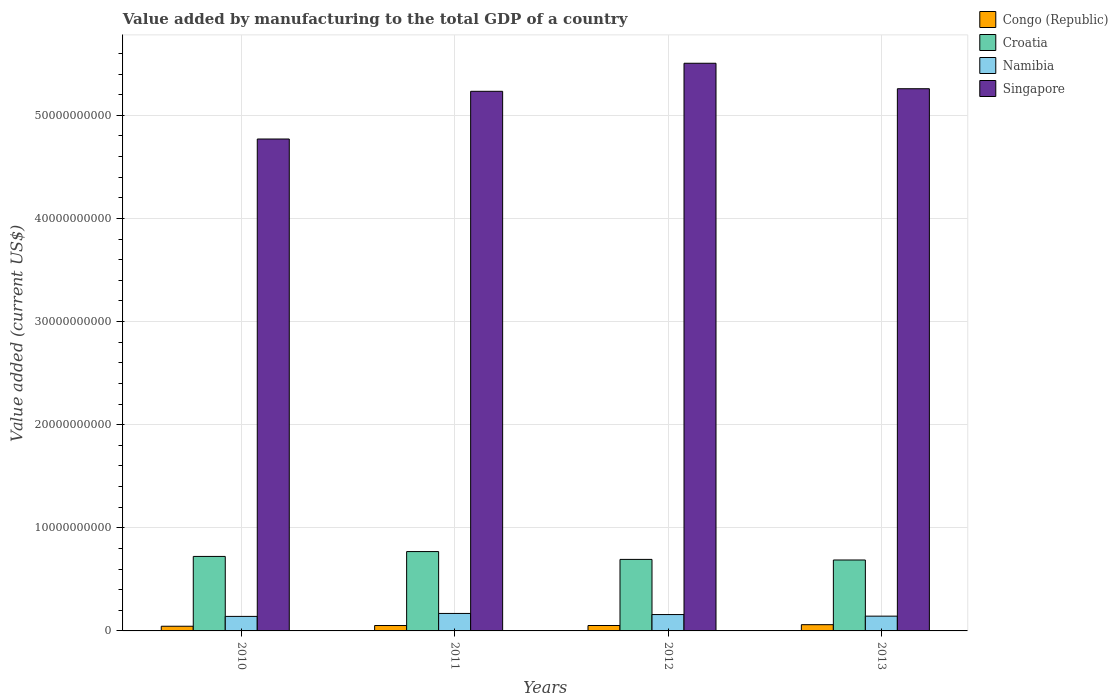How many different coloured bars are there?
Give a very brief answer. 4. How many bars are there on the 1st tick from the left?
Make the answer very short. 4. How many bars are there on the 1st tick from the right?
Provide a short and direct response. 4. What is the label of the 4th group of bars from the left?
Your response must be concise. 2013. In how many cases, is the number of bars for a given year not equal to the number of legend labels?
Provide a succinct answer. 0. What is the value added by manufacturing to the total GDP in Singapore in 2013?
Ensure brevity in your answer.  5.26e+1. Across all years, what is the maximum value added by manufacturing to the total GDP in Namibia?
Offer a very short reply. 1.69e+09. Across all years, what is the minimum value added by manufacturing to the total GDP in Congo (Republic)?
Provide a succinct answer. 4.54e+08. In which year was the value added by manufacturing to the total GDP in Singapore maximum?
Your response must be concise. 2012. What is the total value added by manufacturing to the total GDP in Croatia in the graph?
Give a very brief answer. 2.87e+1. What is the difference between the value added by manufacturing to the total GDP in Singapore in 2011 and that in 2012?
Keep it short and to the point. -2.72e+09. What is the difference between the value added by manufacturing to the total GDP in Congo (Republic) in 2010 and the value added by manufacturing to the total GDP in Croatia in 2012?
Offer a terse response. -6.48e+09. What is the average value added by manufacturing to the total GDP in Croatia per year?
Ensure brevity in your answer.  7.18e+09. In the year 2010, what is the difference between the value added by manufacturing to the total GDP in Singapore and value added by manufacturing to the total GDP in Croatia?
Ensure brevity in your answer.  4.05e+1. What is the ratio of the value added by manufacturing to the total GDP in Croatia in 2010 to that in 2012?
Provide a succinct answer. 1.04. Is the difference between the value added by manufacturing to the total GDP in Singapore in 2010 and 2011 greater than the difference between the value added by manufacturing to the total GDP in Croatia in 2010 and 2011?
Give a very brief answer. No. What is the difference between the highest and the second highest value added by manufacturing to the total GDP in Congo (Republic)?
Keep it short and to the point. 8.02e+07. What is the difference between the highest and the lowest value added by manufacturing to the total GDP in Congo (Republic)?
Your answer should be very brief. 1.51e+08. What does the 2nd bar from the left in 2010 represents?
Offer a terse response. Croatia. What does the 2nd bar from the right in 2013 represents?
Offer a very short reply. Namibia. Is it the case that in every year, the sum of the value added by manufacturing to the total GDP in Congo (Republic) and value added by manufacturing to the total GDP in Namibia is greater than the value added by manufacturing to the total GDP in Singapore?
Offer a very short reply. No. How many bars are there?
Provide a succinct answer. 16. Are all the bars in the graph horizontal?
Your answer should be compact. No. How many years are there in the graph?
Make the answer very short. 4. Does the graph contain any zero values?
Give a very brief answer. No. Does the graph contain grids?
Your answer should be compact. Yes. How many legend labels are there?
Your answer should be very brief. 4. How are the legend labels stacked?
Ensure brevity in your answer.  Vertical. What is the title of the graph?
Offer a very short reply. Value added by manufacturing to the total GDP of a country. What is the label or title of the Y-axis?
Your answer should be very brief. Value added (current US$). What is the Value added (current US$) of Congo (Republic) in 2010?
Your answer should be compact. 4.54e+08. What is the Value added (current US$) of Croatia in 2010?
Offer a terse response. 7.22e+09. What is the Value added (current US$) of Namibia in 2010?
Your answer should be compact. 1.41e+09. What is the Value added (current US$) of Singapore in 2010?
Your response must be concise. 4.77e+1. What is the Value added (current US$) in Congo (Republic) in 2011?
Offer a terse response. 5.24e+08. What is the Value added (current US$) of Croatia in 2011?
Keep it short and to the point. 7.69e+09. What is the Value added (current US$) of Namibia in 2011?
Give a very brief answer. 1.69e+09. What is the Value added (current US$) of Singapore in 2011?
Your answer should be very brief. 5.23e+1. What is the Value added (current US$) of Congo (Republic) in 2012?
Your answer should be very brief. 5.25e+08. What is the Value added (current US$) of Croatia in 2012?
Your answer should be very brief. 6.94e+09. What is the Value added (current US$) of Namibia in 2012?
Make the answer very short. 1.59e+09. What is the Value added (current US$) of Singapore in 2012?
Give a very brief answer. 5.50e+1. What is the Value added (current US$) in Congo (Republic) in 2013?
Offer a terse response. 6.05e+08. What is the Value added (current US$) of Croatia in 2013?
Provide a short and direct response. 6.88e+09. What is the Value added (current US$) of Namibia in 2013?
Provide a short and direct response. 1.43e+09. What is the Value added (current US$) in Singapore in 2013?
Your answer should be very brief. 5.26e+1. Across all years, what is the maximum Value added (current US$) in Congo (Republic)?
Make the answer very short. 6.05e+08. Across all years, what is the maximum Value added (current US$) in Croatia?
Your answer should be very brief. 7.69e+09. Across all years, what is the maximum Value added (current US$) in Namibia?
Make the answer very short. 1.69e+09. Across all years, what is the maximum Value added (current US$) in Singapore?
Keep it short and to the point. 5.50e+1. Across all years, what is the minimum Value added (current US$) in Congo (Republic)?
Ensure brevity in your answer.  4.54e+08. Across all years, what is the minimum Value added (current US$) in Croatia?
Provide a short and direct response. 6.88e+09. Across all years, what is the minimum Value added (current US$) in Namibia?
Provide a succinct answer. 1.41e+09. Across all years, what is the minimum Value added (current US$) in Singapore?
Offer a very short reply. 4.77e+1. What is the total Value added (current US$) of Congo (Republic) in the graph?
Your answer should be very brief. 2.11e+09. What is the total Value added (current US$) in Croatia in the graph?
Ensure brevity in your answer.  2.87e+1. What is the total Value added (current US$) in Namibia in the graph?
Give a very brief answer. 6.12e+09. What is the total Value added (current US$) of Singapore in the graph?
Offer a very short reply. 2.08e+11. What is the difference between the Value added (current US$) in Congo (Republic) in 2010 and that in 2011?
Offer a very short reply. -6.98e+07. What is the difference between the Value added (current US$) in Croatia in 2010 and that in 2011?
Give a very brief answer. -4.71e+08. What is the difference between the Value added (current US$) in Namibia in 2010 and that in 2011?
Give a very brief answer. -2.87e+08. What is the difference between the Value added (current US$) in Singapore in 2010 and that in 2011?
Offer a very short reply. -4.63e+09. What is the difference between the Value added (current US$) of Congo (Republic) in 2010 and that in 2012?
Your answer should be very brief. -7.08e+07. What is the difference between the Value added (current US$) in Croatia in 2010 and that in 2012?
Provide a short and direct response. 2.88e+08. What is the difference between the Value added (current US$) of Namibia in 2010 and that in 2012?
Keep it short and to the point. -1.79e+08. What is the difference between the Value added (current US$) in Singapore in 2010 and that in 2012?
Make the answer very short. -7.35e+09. What is the difference between the Value added (current US$) of Congo (Republic) in 2010 and that in 2013?
Your answer should be very brief. -1.51e+08. What is the difference between the Value added (current US$) of Croatia in 2010 and that in 2013?
Offer a very short reply. 3.45e+08. What is the difference between the Value added (current US$) in Namibia in 2010 and that in 2013?
Your answer should be very brief. -2.44e+07. What is the difference between the Value added (current US$) of Singapore in 2010 and that in 2013?
Give a very brief answer. -4.88e+09. What is the difference between the Value added (current US$) in Congo (Republic) in 2011 and that in 2012?
Your answer should be compact. -9.99e+05. What is the difference between the Value added (current US$) of Croatia in 2011 and that in 2012?
Your response must be concise. 7.59e+08. What is the difference between the Value added (current US$) in Namibia in 2011 and that in 2012?
Offer a terse response. 1.08e+08. What is the difference between the Value added (current US$) in Singapore in 2011 and that in 2012?
Your response must be concise. -2.72e+09. What is the difference between the Value added (current US$) in Congo (Republic) in 2011 and that in 2013?
Provide a succinct answer. -8.12e+07. What is the difference between the Value added (current US$) in Croatia in 2011 and that in 2013?
Make the answer very short. 8.16e+08. What is the difference between the Value added (current US$) in Namibia in 2011 and that in 2013?
Offer a terse response. 2.62e+08. What is the difference between the Value added (current US$) in Singapore in 2011 and that in 2013?
Make the answer very short. -2.50e+08. What is the difference between the Value added (current US$) in Congo (Republic) in 2012 and that in 2013?
Your answer should be very brief. -8.02e+07. What is the difference between the Value added (current US$) of Croatia in 2012 and that in 2013?
Give a very brief answer. 5.71e+07. What is the difference between the Value added (current US$) of Namibia in 2012 and that in 2013?
Your answer should be compact. 1.55e+08. What is the difference between the Value added (current US$) in Singapore in 2012 and that in 2013?
Offer a terse response. 2.47e+09. What is the difference between the Value added (current US$) of Congo (Republic) in 2010 and the Value added (current US$) of Croatia in 2011?
Offer a very short reply. -7.24e+09. What is the difference between the Value added (current US$) in Congo (Republic) in 2010 and the Value added (current US$) in Namibia in 2011?
Provide a succinct answer. -1.24e+09. What is the difference between the Value added (current US$) of Congo (Republic) in 2010 and the Value added (current US$) of Singapore in 2011?
Your answer should be compact. -5.19e+1. What is the difference between the Value added (current US$) of Croatia in 2010 and the Value added (current US$) of Namibia in 2011?
Offer a very short reply. 5.53e+09. What is the difference between the Value added (current US$) of Croatia in 2010 and the Value added (current US$) of Singapore in 2011?
Your answer should be very brief. -4.51e+1. What is the difference between the Value added (current US$) in Namibia in 2010 and the Value added (current US$) in Singapore in 2011?
Provide a succinct answer. -5.09e+1. What is the difference between the Value added (current US$) in Congo (Republic) in 2010 and the Value added (current US$) in Croatia in 2012?
Your answer should be very brief. -6.48e+09. What is the difference between the Value added (current US$) in Congo (Republic) in 2010 and the Value added (current US$) in Namibia in 2012?
Keep it short and to the point. -1.13e+09. What is the difference between the Value added (current US$) of Congo (Republic) in 2010 and the Value added (current US$) of Singapore in 2012?
Your answer should be very brief. -5.46e+1. What is the difference between the Value added (current US$) in Croatia in 2010 and the Value added (current US$) in Namibia in 2012?
Your answer should be very brief. 5.64e+09. What is the difference between the Value added (current US$) in Croatia in 2010 and the Value added (current US$) in Singapore in 2012?
Offer a terse response. -4.78e+1. What is the difference between the Value added (current US$) of Namibia in 2010 and the Value added (current US$) of Singapore in 2012?
Your answer should be very brief. -5.36e+1. What is the difference between the Value added (current US$) in Congo (Republic) in 2010 and the Value added (current US$) in Croatia in 2013?
Your response must be concise. -6.42e+09. What is the difference between the Value added (current US$) in Congo (Republic) in 2010 and the Value added (current US$) in Namibia in 2013?
Give a very brief answer. -9.78e+08. What is the difference between the Value added (current US$) of Congo (Republic) in 2010 and the Value added (current US$) of Singapore in 2013?
Ensure brevity in your answer.  -5.21e+1. What is the difference between the Value added (current US$) in Croatia in 2010 and the Value added (current US$) in Namibia in 2013?
Make the answer very short. 5.79e+09. What is the difference between the Value added (current US$) in Croatia in 2010 and the Value added (current US$) in Singapore in 2013?
Make the answer very short. -4.54e+1. What is the difference between the Value added (current US$) of Namibia in 2010 and the Value added (current US$) of Singapore in 2013?
Make the answer very short. -5.12e+1. What is the difference between the Value added (current US$) in Congo (Republic) in 2011 and the Value added (current US$) in Croatia in 2012?
Make the answer very short. -6.41e+09. What is the difference between the Value added (current US$) in Congo (Republic) in 2011 and the Value added (current US$) in Namibia in 2012?
Your answer should be very brief. -1.06e+09. What is the difference between the Value added (current US$) of Congo (Republic) in 2011 and the Value added (current US$) of Singapore in 2012?
Your response must be concise. -5.45e+1. What is the difference between the Value added (current US$) of Croatia in 2011 and the Value added (current US$) of Namibia in 2012?
Offer a terse response. 6.11e+09. What is the difference between the Value added (current US$) of Croatia in 2011 and the Value added (current US$) of Singapore in 2012?
Offer a terse response. -4.74e+1. What is the difference between the Value added (current US$) of Namibia in 2011 and the Value added (current US$) of Singapore in 2012?
Keep it short and to the point. -5.34e+1. What is the difference between the Value added (current US$) in Congo (Republic) in 2011 and the Value added (current US$) in Croatia in 2013?
Your response must be concise. -6.35e+09. What is the difference between the Value added (current US$) of Congo (Republic) in 2011 and the Value added (current US$) of Namibia in 2013?
Keep it short and to the point. -9.08e+08. What is the difference between the Value added (current US$) in Congo (Republic) in 2011 and the Value added (current US$) in Singapore in 2013?
Keep it short and to the point. -5.21e+1. What is the difference between the Value added (current US$) of Croatia in 2011 and the Value added (current US$) of Namibia in 2013?
Ensure brevity in your answer.  6.26e+09. What is the difference between the Value added (current US$) of Croatia in 2011 and the Value added (current US$) of Singapore in 2013?
Ensure brevity in your answer.  -4.49e+1. What is the difference between the Value added (current US$) of Namibia in 2011 and the Value added (current US$) of Singapore in 2013?
Your answer should be compact. -5.09e+1. What is the difference between the Value added (current US$) in Congo (Republic) in 2012 and the Value added (current US$) in Croatia in 2013?
Keep it short and to the point. -6.35e+09. What is the difference between the Value added (current US$) in Congo (Republic) in 2012 and the Value added (current US$) in Namibia in 2013?
Your answer should be very brief. -9.07e+08. What is the difference between the Value added (current US$) in Congo (Republic) in 2012 and the Value added (current US$) in Singapore in 2013?
Provide a short and direct response. -5.21e+1. What is the difference between the Value added (current US$) in Croatia in 2012 and the Value added (current US$) in Namibia in 2013?
Your answer should be compact. 5.50e+09. What is the difference between the Value added (current US$) in Croatia in 2012 and the Value added (current US$) in Singapore in 2013?
Ensure brevity in your answer.  -4.56e+1. What is the difference between the Value added (current US$) in Namibia in 2012 and the Value added (current US$) in Singapore in 2013?
Provide a succinct answer. -5.10e+1. What is the average Value added (current US$) in Congo (Republic) per year?
Your answer should be very brief. 5.27e+08. What is the average Value added (current US$) of Croatia per year?
Your answer should be compact. 7.18e+09. What is the average Value added (current US$) in Namibia per year?
Offer a very short reply. 1.53e+09. What is the average Value added (current US$) of Singapore per year?
Offer a terse response. 5.19e+1. In the year 2010, what is the difference between the Value added (current US$) of Congo (Republic) and Value added (current US$) of Croatia?
Give a very brief answer. -6.77e+09. In the year 2010, what is the difference between the Value added (current US$) in Congo (Republic) and Value added (current US$) in Namibia?
Offer a very short reply. -9.53e+08. In the year 2010, what is the difference between the Value added (current US$) of Congo (Republic) and Value added (current US$) of Singapore?
Your answer should be very brief. -4.72e+1. In the year 2010, what is the difference between the Value added (current US$) in Croatia and Value added (current US$) in Namibia?
Provide a succinct answer. 5.82e+09. In the year 2010, what is the difference between the Value added (current US$) in Croatia and Value added (current US$) in Singapore?
Offer a very short reply. -4.05e+1. In the year 2010, what is the difference between the Value added (current US$) of Namibia and Value added (current US$) of Singapore?
Keep it short and to the point. -4.63e+1. In the year 2011, what is the difference between the Value added (current US$) of Congo (Republic) and Value added (current US$) of Croatia?
Keep it short and to the point. -7.17e+09. In the year 2011, what is the difference between the Value added (current US$) in Congo (Republic) and Value added (current US$) in Namibia?
Your answer should be very brief. -1.17e+09. In the year 2011, what is the difference between the Value added (current US$) of Congo (Republic) and Value added (current US$) of Singapore?
Your answer should be compact. -5.18e+1. In the year 2011, what is the difference between the Value added (current US$) of Croatia and Value added (current US$) of Namibia?
Provide a succinct answer. 6.00e+09. In the year 2011, what is the difference between the Value added (current US$) in Croatia and Value added (current US$) in Singapore?
Offer a very short reply. -4.46e+1. In the year 2011, what is the difference between the Value added (current US$) in Namibia and Value added (current US$) in Singapore?
Offer a terse response. -5.06e+1. In the year 2012, what is the difference between the Value added (current US$) in Congo (Republic) and Value added (current US$) in Croatia?
Ensure brevity in your answer.  -6.41e+09. In the year 2012, what is the difference between the Value added (current US$) in Congo (Republic) and Value added (current US$) in Namibia?
Offer a terse response. -1.06e+09. In the year 2012, what is the difference between the Value added (current US$) of Congo (Republic) and Value added (current US$) of Singapore?
Your answer should be compact. -5.45e+1. In the year 2012, what is the difference between the Value added (current US$) in Croatia and Value added (current US$) in Namibia?
Give a very brief answer. 5.35e+09. In the year 2012, what is the difference between the Value added (current US$) of Croatia and Value added (current US$) of Singapore?
Your answer should be compact. -4.81e+1. In the year 2012, what is the difference between the Value added (current US$) in Namibia and Value added (current US$) in Singapore?
Ensure brevity in your answer.  -5.35e+1. In the year 2013, what is the difference between the Value added (current US$) in Congo (Republic) and Value added (current US$) in Croatia?
Your response must be concise. -6.27e+09. In the year 2013, what is the difference between the Value added (current US$) of Congo (Republic) and Value added (current US$) of Namibia?
Keep it short and to the point. -8.27e+08. In the year 2013, what is the difference between the Value added (current US$) of Congo (Republic) and Value added (current US$) of Singapore?
Provide a succinct answer. -5.20e+1. In the year 2013, what is the difference between the Value added (current US$) in Croatia and Value added (current US$) in Namibia?
Your answer should be very brief. 5.45e+09. In the year 2013, what is the difference between the Value added (current US$) of Croatia and Value added (current US$) of Singapore?
Your answer should be compact. -4.57e+1. In the year 2013, what is the difference between the Value added (current US$) of Namibia and Value added (current US$) of Singapore?
Ensure brevity in your answer.  -5.11e+1. What is the ratio of the Value added (current US$) in Congo (Republic) in 2010 to that in 2011?
Provide a short and direct response. 0.87. What is the ratio of the Value added (current US$) in Croatia in 2010 to that in 2011?
Make the answer very short. 0.94. What is the ratio of the Value added (current US$) in Namibia in 2010 to that in 2011?
Offer a very short reply. 0.83. What is the ratio of the Value added (current US$) of Singapore in 2010 to that in 2011?
Offer a very short reply. 0.91. What is the ratio of the Value added (current US$) of Congo (Republic) in 2010 to that in 2012?
Keep it short and to the point. 0.87. What is the ratio of the Value added (current US$) in Croatia in 2010 to that in 2012?
Make the answer very short. 1.04. What is the ratio of the Value added (current US$) in Namibia in 2010 to that in 2012?
Ensure brevity in your answer.  0.89. What is the ratio of the Value added (current US$) of Singapore in 2010 to that in 2012?
Make the answer very short. 0.87. What is the ratio of the Value added (current US$) of Congo (Republic) in 2010 to that in 2013?
Make the answer very short. 0.75. What is the ratio of the Value added (current US$) of Croatia in 2010 to that in 2013?
Offer a terse response. 1.05. What is the ratio of the Value added (current US$) in Namibia in 2010 to that in 2013?
Offer a very short reply. 0.98. What is the ratio of the Value added (current US$) in Singapore in 2010 to that in 2013?
Ensure brevity in your answer.  0.91. What is the ratio of the Value added (current US$) in Congo (Republic) in 2011 to that in 2012?
Your answer should be very brief. 1. What is the ratio of the Value added (current US$) in Croatia in 2011 to that in 2012?
Your response must be concise. 1.11. What is the ratio of the Value added (current US$) in Namibia in 2011 to that in 2012?
Provide a short and direct response. 1.07. What is the ratio of the Value added (current US$) of Singapore in 2011 to that in 2012?
Keep it short and to the point. 0.95. What is the ratio of the Value added (current US$) in Congo (Republic) in 2011 to that in 2013?
Your answer should be compact. 0.87. What is the ratio of the Value added (current US$) of Croatia in 2011 to that in 2013?
Give a very brief answer. 1.12. What is the ratio of the Value added (current US$) in Namibia in 2011 to that in 2013?
Your response must be concise. 1.18. What is the ratio of the Value added (current US$) in Congo (Republic) in 2012 to that in 2013?
Your response must be concise. 0.87. What is the ratio of the Value added (current US$) of Croatia in 2012 to that in 2013?
Your answer should be compact. 1.01. What is the ratio of the Value added (current US$) of Namibia in 2012 to that in 2013?
Your answer should be very brief. 1.11. What is the ratio of the Value added (current US$) of Singapore in 2012 to that in 2013?
Offer a terse response. 1.05. What is the difference between the highest and the second highest Value added (current US$) in Congo (Republic)?
Your answer should be compact. 8.02e+07. What is the difference between the highest and the second highest Value added (current US$) in Croatia?
Make the answer very short. 4.71e+08. What is the difference between the highest and the second highest Value added (current US$) of Namibia?
Give a very brief answer. 1.08e+08. What is the difference between the highest and the second highest Value added (current US$) in Singapore?
Make the answer very short. 2.47e+09. What is the difference between the highest and the lowest Value added (current US$) in Congo (Republic)?
Give a very brief answer. 1.51e+08. What is the difference between the highest and the lowest Value added (current US$) in Croatia?
Ensure brevity in your answer.  8.16e+08. What is the difference between the highest and the lowest Value added (current US$) of Namibia?
Your answer should be compact. 2.87e+08. What is the difference between the highest and the lowest Value added (current US$) of Singapore?
Make the answer very short. 7.35e+09. 